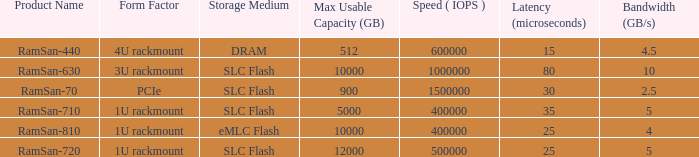List the number of ramsan-720 hard drives? 1.0. 